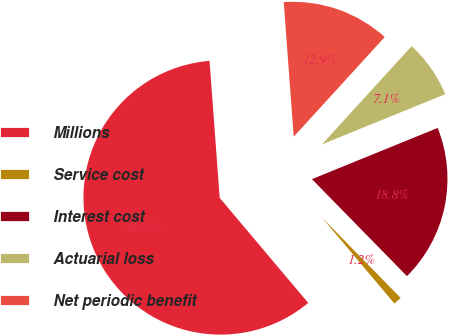Convert chart. <chart><loc_0><loc_0><loc_500><loc_500><pie_chart><fcel>Millions<fcel>Service cost<fcel>Interest cost<fcel>Actuarial loss<fcel>Net periodic benefit<nl><fcel>59.97%<fcel>1.19%<fcel>18.82%<fcel>7.07%<fcel>12.95%<nl></chart> 